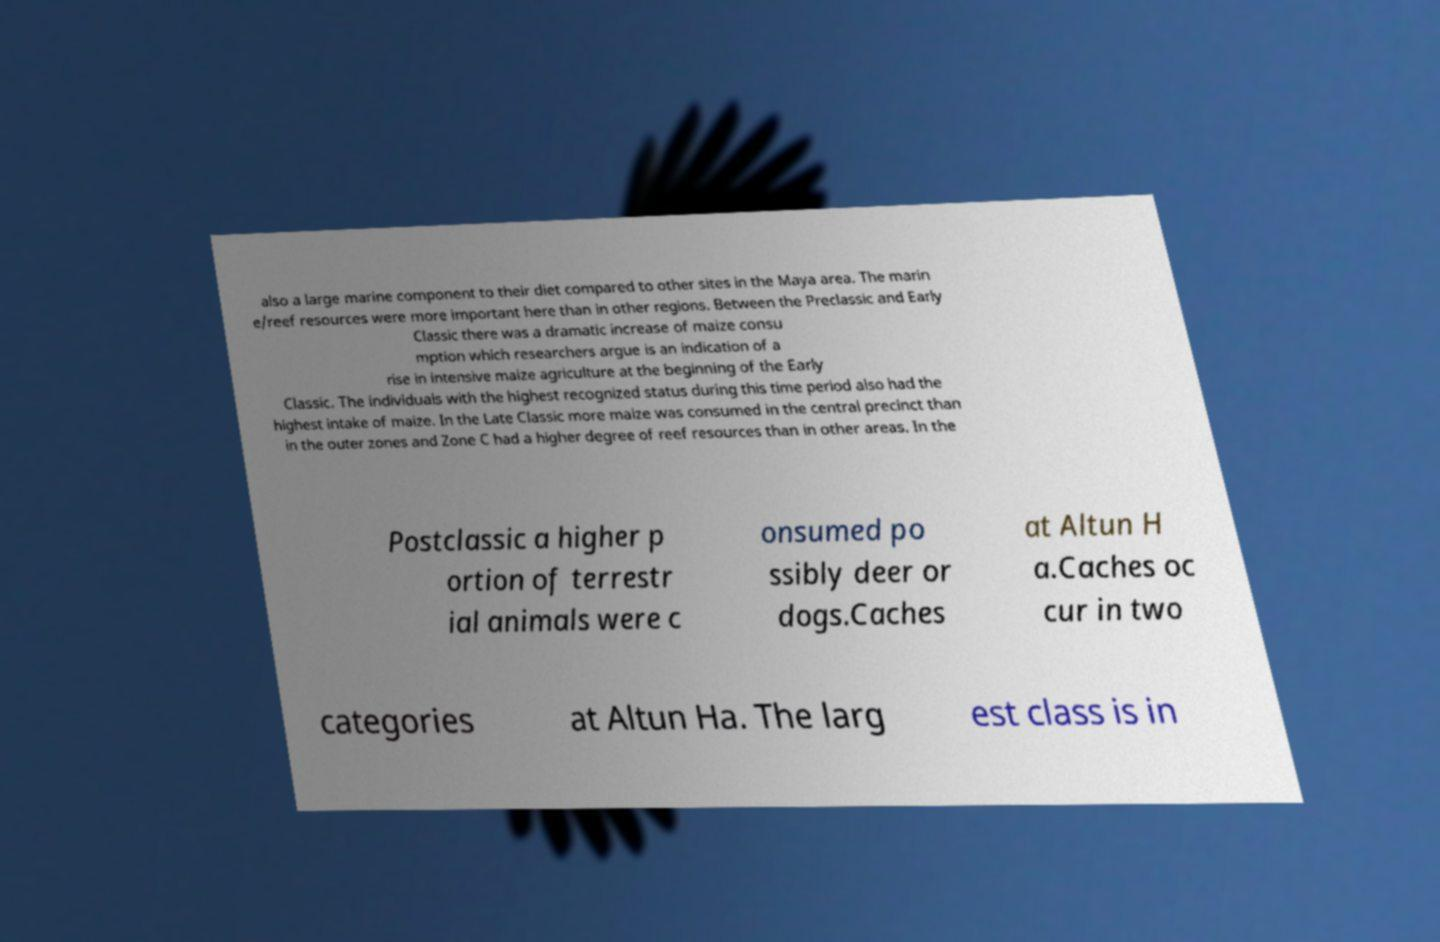What messages or text are displayed in this image? I need them in a readable, typed format. also a large marine component to their diet compared to other sites in the Maya area. The marin e/reef resources were more important here than in other regions. Between the Preclassic and Early Classic there was a dramatic increase of maize consu mption which researchers argue is an indication of a rise in intensive maize agriculture at the beginning of the Early Classic. The individuals with the highest recognized status during this time period also had the highest intake of maize. In the Late Classic more maize was consumed in the central precinct than in the outer zones and Zone C had a higher degree of reef resources than in other areas. In the Postclassic a higher p ortion of terrestr ial animals were c onsumed po ssibly deer or dogs.Caches at Altun H a.Caches oc cur in two categories at Altun Ha. The larg est class is in 